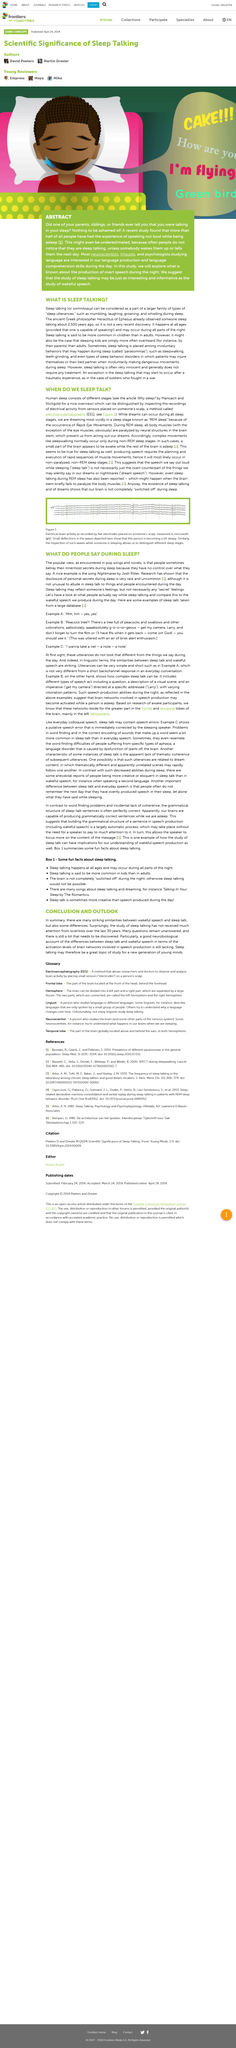Highlight a few significant elements in this photo. For the past 30 years, the study of sleep has not received much attention. In their sleep, people commonly express thoughts and feelings, but any secrets they may have are not necessarily shared. What is the title about? It is about conclusions and outlooks. It is very rare and uncommon for personal secrets to be disclosed when asleep. The popular view of sleep-talking is that people may inadvertently reveal their secrets when they sleep-talk. 